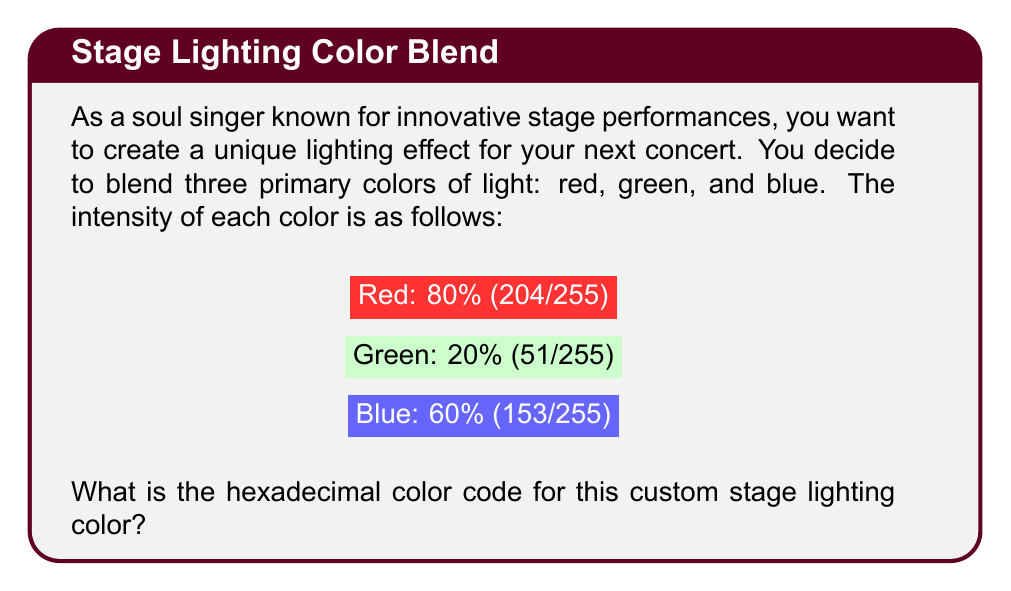Show me your answer to this math problem. To determine the hexadecimal color code, we need to follow these steps:

1. Convert the given percentages to decimal values (0-255):
   Red: 80% = 204
   Green: 20% = 51
   Blue: 60% = 153

2. Convert each decimal value to hexadecimal:
   Red: 204 in decimal = CC in hexadecimal
   $204 \div 16 = 12$ remainder $12$, so we get CC

   Green: 51 in decimal = 33 in hexadecimal
   $51 \div 16 = 3$ remainder $3$, so we get 33

   Blue: 153 in decimal = 99 in hexadecimal
   $153 \div 16 = 9$ remainder $9$, so we get 99

3. Combine the hexadecimal values in the order RGB:
   Red (CC) + Green (33) + Blue (99) = CC3399

Therefore, the hexadecimal color code for the custom stage lighting color is #CC3399.
Answer: #CC3399 